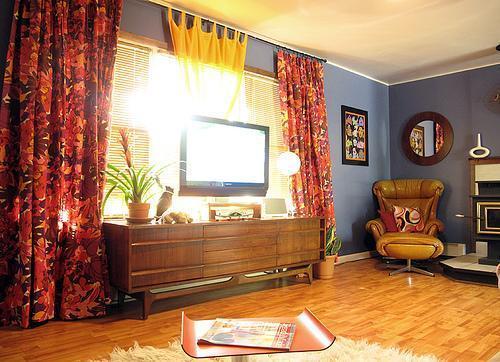How many people on the train are sitting next to a window that opens?
Give a very brief answer. 0. 